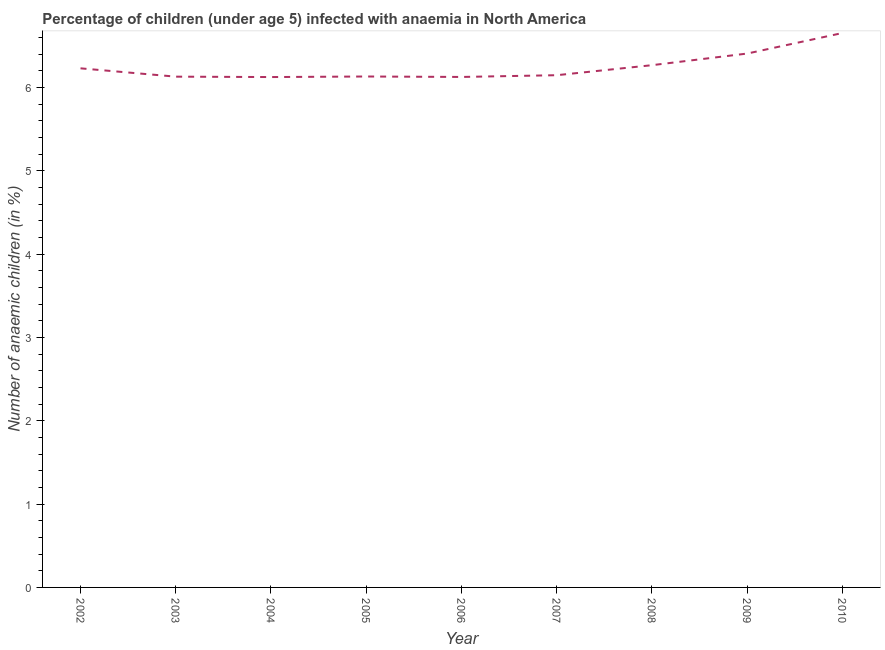What is the number of anaemic children in 2004?
Keep it short and to the point. 6.13. Across all years, what is the maximum number of anaemic children?
Your answer should be very brief. 6.66. Across all years, what is the minimum number of anaemic children?
Make the answer very short. 6.13. What is the sum of the number of anaemic children?
Ensure brevity in your answer.  56.24. What is the difference between the number of anaemic children in 2002 and 2009?
Keep it short and to the point. -0.18. What is the average number of anaemic children per year?
Keep it short and to the point. 6.25. What is the median number of anaemic children?
Offer a terse response. 6.15. What is the ratio of the number of anaemic children in 2009 to that in 2010?
Your answer should be compact. 0.96. Is the number of anaemic children in 2003 less than that in 2005?
Your answer should be very brief. Yes. Is the difference between the number of anaemic children in 2002 and 2004 greater than the difference between any two years?
Your answer should be compact. No. What is the difference between the highest and the second highest number of anaemic children?
Make the answer very short. 0.25. Is the sum of the number of anaemic children in 2006 and 2009 greater than the maximum number of anaemic children across all years?
Offer a very short reply. Yes. What is the difference between the highest and the lowest number of anaemic children?
Ensure brevity in your answer.  0.53. Does the number of anaemic children monotonically increase over the years?
Keep it short and to the point. No. What is the difference between two consecutive major ticks on the Y-axis?
Offer a terse response. 1. Are the values on the major ticks of Y-axis written in scientific E-notation?
Your answer should be very brief. No. Does the graph contain any zero values?
Provide a succinct answer. No. Does the graph contain grids?
Ensure brevity in your answer.  No. What is the title of the graph?
Provide a succinct answer. Percentage of children (under age 5) infected with anaemia in North America. What is the label or title of the X-axis?
Provide a short and direct response. Year. What is the label or title of the Y-axis?
Provide a short and direct response. Number of anaemic children (in %). What is the Number of anaemic children (in %) of 2002?
Offer a terse response. 6.23. What is the Number of anaemic children (in %) in 2003?
Provide a short and direct response. 6.13. What is the Number of anaemic children (in %) in 2004?
Keep it short and to the point. 6.13. What is the Number of anaemic children (in %) in 2005?
Your answer should be very brief. 6.13. What is the Number of anaemic children (in %) in 2006?
Offer a very short reply. 6.13. What is the Number of anaemic children (in %) in 2007?
Provide a short and direct response. 6.15. What is the Number of anaemic children (in %) of 2008?
Ensure brevity in your answer.  6.27. What is the Number of anaemic children (in %) of 2009?
Keep it short and to the point. 6.41. What is the Number of anaemic children (in %) of 2010?
Your answer should be compact. 6.66. What is the difference between the Number of anaemic children (in %) in 2002 and 2003?
Offer a very short reply. 0.1. What is the difference between the Number of anaemic children (in %) in 2002 and 2004?
Your answer should be very brief. 0.1. What is the difference between the Number of anaemic children (in %) in 2002 and 2005?
Offer a very short reply. 0.1. What is the difference between the Number of anaemic children (in %) in 2002 and 2006?
Provide a succinct answer. 0.1. What is the difference between the Number of anaemic children (in %) in 2002 and 2007?
Offer a terse response. 0.08. What is the difference between the Number of anaemic children (in %) in 2002 and 2008?
Offer a terse response. -0.04. What is the difference between the Number of anaemic children (in %) in 2002 and 2009?
Offer a terse response. -0.18. What is the difference between the Number of anaemic children (in %) in 2002 and 2010?
Keep it short and to the point. -0.42. What is the difference between the Number of anaemic children (in %) in 2003 and 2004?
Offer a very short reply. 0. What is the difference between the Number of anaemic children (in %) in 2003 and 2005?
Provide a short and direct response. -0. What is the difference between the Number of anaemic children (in %) in 2003 and 2006?
Provide a succinct answer. 0. What is the difference between the Number of anaemic children (in %) in 2003 and 2007?
Provide a short and direct response. -0.02. What is the difference between the Number of anaemic children (in %) in 2003 and 2008?
Ensure brevity in your answer.  -0.14. What is the difference between the Number of anaemic children (in %) in 2003 and 2009?
Give a very brief answer. -0.28. What is the difference between the Number of anaemic children (in %) in 2003 and 2010?
Keep it short and to the point. -0.52. What is the difference between the Number of anaemic children (in %) in 2004 and 2005?
Provide a succinct answer. -0.01. What is the difference between the Number of anaemic children (in %) in 2004 and 2006?
Make the answer very short. -0. What is the difference between the Number of anaemic children (in %) in 2004 and 2007?
Your answer should be very brief. -0.02. What is the difference between the Number of anaemic children (in %) in 2004 and 2008?
Provide a short and direct response. -0.14. What is the difference between the Number of anaemic children (in %) in 2004 and 2009?
Offer a terse response. -0.28. What is the difference between the Number of anaemic children (in %) in 2004 and 2010?
Your response must be concise. -0.53. What is the difference between the Number of anaemic children (in %) in 2005 and 2006?
Provide a short and direct response. 0.01. What is the difference between the Number of anaemic children (in %) in 2005 and 2007?
Offer a terse response. -0.02. What is the difference between the Number of anaemic children (in %) in 2005 and 2008?
Offer a very short reply. -0.14. What is the difference between the Number of anaemic children (in %) in 2005 and 2009?
Provide a succinct answer. -0.28. What is the difference between the Number of anaemic children (in %) in 2005 and 2010?
Provide a short and direct response. -0.52. What is the difference between the Number of anaemic children (in %) in 2006 and 2007?
Your answer should be compact. -0.02. What is the difference between the Number of anaemic children (in %) in 2006 and 2008?
Provide a short and direct response. -0.14. What is the difference between the Number of anaemic children (in %) in 2006 and 2009?
Keep it short and to the point. -0.28. What is the difference between the Number of anaemic children (in %) in 2006 and 2010?
Your response must be concise. -0.53. What is the difference between the Number of anaemic children (in %) in 2007 and 2008?
Your answer should be very brief. -0.12. What is the difference between the Number of anaemic children (in %) in 2007 and 2009?
Provide a short and direct response. -0.26. What is the difference between the Number of anaemic children (in %) in 2007 and 2010?
Offer a very short reply. -0.51. What is the difference between the Number of anaemic children (in %) in 2008 and 2009?
Make the answer very short. -0.14. What is the difference between the Number of anaemic children (in %) in 2008 and 2010?
Ensure brevity in your answer.  -0.39. What is the difference between the Number of anaemic children (in %) in 2009 and 2010?
Provide a short and direct response. -0.25. What is the ratio of the Number of anaemic children (in %) in 2002 to that in 2003?
Ensure brevity in your answer.  1.02. What is the ratio of the Number of anaemic children (in %) in 2002 to that in 2004?
Give a very brief answer. 1.02. What is the ratio of the Number of anaemic children (in %) in 2002 to that in 2005?
Ensure brevity in your answer.  1.02. What is the ratio of the Number of anaemic children (in %) in 2002 to that in 2007?
Your response must be concise. 1.01. What is the ratio of the Number of anaemic children (in %) in 2002 to that in 2008?
Your answer should be compact. 0.99. What is the ratio of the Number of anaemic children (in %) in 2002 to that in 2010?
Provide a short and direct response. 0.94. What is the ratio of the Number of anaemic children (in %) in 2003 to that in 2005?
Give a very brief answer. 1. What is the ratio of the Number of anaemic children (in %) in 2003 to that in 2007?
Your answer should be compact. 1. What is the ratio of the Number of anaemic children (in %) in 2003 to that in 2008?
Make the answer very short. 0.98. What is the ratio of the Number of anaemic children (in %) in 2003 to that in 2009?
Provide a short and direct response. 0.96. What is the ratio of the Number of anaemic children (in %) in 2003 to that in 2010?
Your answer should be compact. 0.92. What is the ratio of the Number of anaemic children (in %) in 2004 to that in 2006?
Your answer should be compact. 1. What is the ratio of the Number of anaemic children (in %) in 2004 to that in 2008?
Provide a succinct answer. 0.98. What is the ratio of the Number of anaemic children (in %) in 2004 to that in 2009?
Your answer should be very brief. 0.96. What is the ratio of the Number of anaemic children (in %) in 2004 to that in 2010?
Offer a terse response. 0.92. What is the ratio of the Number of anaemic children (in %) in 2005 to that in 2006?
Give a very brief answer. 1. What is the ratio of the Number of anaemic children (in %) in 2005 to that in 2008?
Keep it short and to the point. 0.98. What is the ratio of the Number of anaemic children (in %) in 2005 to that in 2010?
Offer a very short reply. 0.92. What is the ratio of the Number of anaemic children (in %) in 2006 to that in 2007?
Keep it short and to the point. 1. What is the ratio of the Number of anaemic children (in %) in 2006 to that in 2008?
Your answer should be very brief. 0.98. What is the ratio of the Number of anaemic children (in %) in 2006 to that in 2009?
Offer a terse response. 0.96. What is the ratio of the Number of anaemic children (in %) in 2006 to that in 2010?
Your answer should be very brief. 0.92. What is the ratio of the Number of anaemic children (in %) in 2007 to that in 2010?
Provide a short and direct response. 0.92. What is the ratio of the Number of anaemic children (in %) in 2008 to that in 2010?
Your answer should be compact. 0.94. What is the ratio of the Number of anaemic children (in %) in 2009 to that in 2010?
Ensure brevity in your answer.  0.96. 